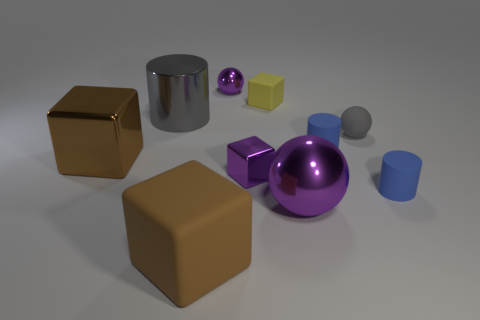Is the color of the block in front of the small purple block the same as the large metallic cube?
Your answer should be compact. Yes. How many objects are either large things that are behind the large ball or large gray cylinders?
Your answer should be very brief. 2. There is a small sphere that is in front of the tiny yellow rubber block to the right of the purple thing that is behind the small yellow matte thing; what is it made of?
Make the answer very short. Rubber. Are there more big metallic things on the left side of the brown matte block than brown metal objects that are to the right of the small gray matte sphere?
Provide a short and direct response. Yes. What number of spheres are big things or brown objects?
Your response must be concise. 1. What number of shiny objects are on the left side of the tiny purple shiny thing that is on the left side of the small purple thing right of the tiny purple sphere?
Give a very brief answer. 2. There is a big cylinder that is the same color as the small matte ball; what material is it?
Your answer should be compact. Metal. Is the number of shiny cubes greater than the number of purple objects?
Provide a succinct answer. No. Do the brown matte cube and the brown shiny thing have the same size?
Your answer should be compact. Yes. What number of things are gray objects or brown objects?
Give a very brief answer. 4. 